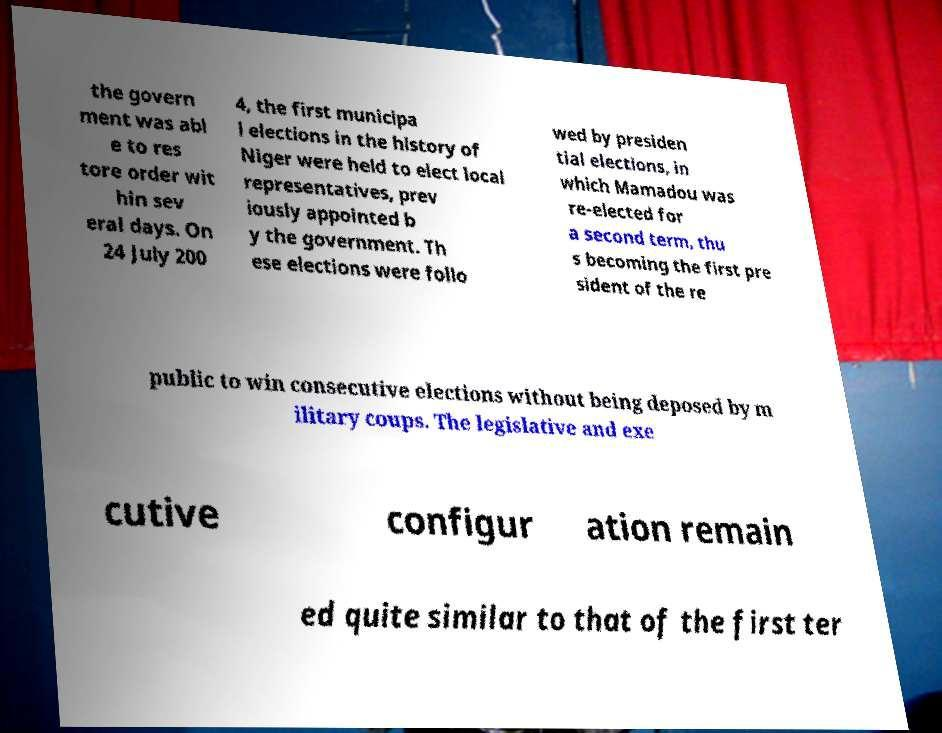For documentation purposes, I need the text within this image transcribed. Could you provide that? the govern ment was abl e to res tore order wit hin sev eral days. On 24 July 200 4, the first municipa l elections in the history of Niger were held to elect local representatives, prev iously appointed b y the government. Th ese elections were follo wed by presiden tial elections, in which Mamadou was re-elected for a second term, thu s becoming the first pre sident of the re public to win consecutive elections without being deposed by m ilitary coups. The legislative and exe cutive configur ation remain ed quite similar to that of the first ter 